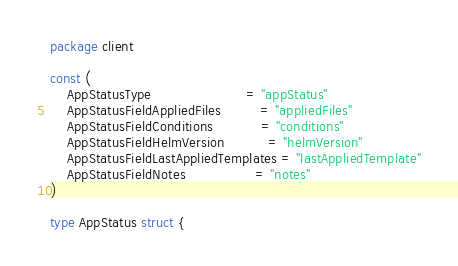<code> <loc_0><loc_0><loc_500><loc_500><_Go_>package client

const (
	AppStatusType                      = "appStatus"
	AppStatusFieldAppliedFiles         = "appliedFiles"
	AppStatusFieldConditions           = "conditions"
	AppStatusFieldHelmVersion          = "helmVersion"
	AppStatusFieldLastAppliedTemplates = "lastAppliedTemplate"
	AppStatusFieldNotes                = "notes"
)

type AppStatus struct {</code> 